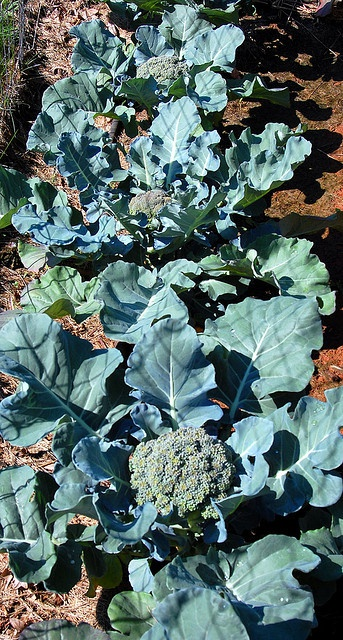Describe the objects in this image and their specific colors. I can see broccoli in darkgreen, black, darkgray, beige, and gray tones, broccoli in darkgreen, lightgray, darkgray, gray, and black tones, and broccoli in darkgreen, darkgray, lightgray, gray, and black tones in this image. 